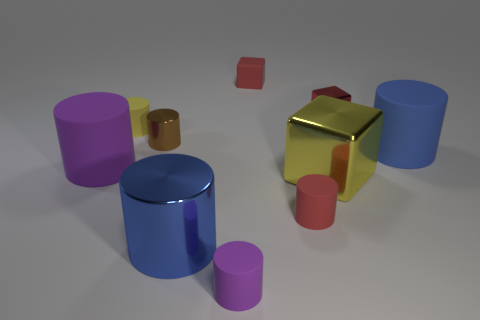What number of other objects are the same size as the blue matte object?
Provide a short and direct response. 3. Is the tiny purple object made of the same material as the tiny red cylinder?
Give a very brief answer. Yes. What color is the small cylinder that is behind the small metallic object that is to the left of the small metal cube?
Offer a very short reply. Yellow. There is a brown object that is the same shape as the blue matte object; what is its size?
Your answer should be very brief. Small. Does the small matte block have the same color as the tiny metallic cube?
Your response must be concise. Yes. There is a block that is in front of the tiny matte object to the left of the large metallic cylinder; what number of metal cubes are right of it?
Provide a short and direct response. 1. Are there more small red metal things than tiny gray cylinders?
Give a very brief answer. Yes. What number of large blue cylinders are there?
Give a very brief answer. 2. What shape is the big object that is to the left of the blue thing to the left of the purple object that is in front of the large purple matte thing?
Ensure brevity in your answer.  Cylinder. Are there fewer big yellow cubes left of the large yellow block than tiny cylinders behind the large purple thing?
Offer a terse response. Yes. 